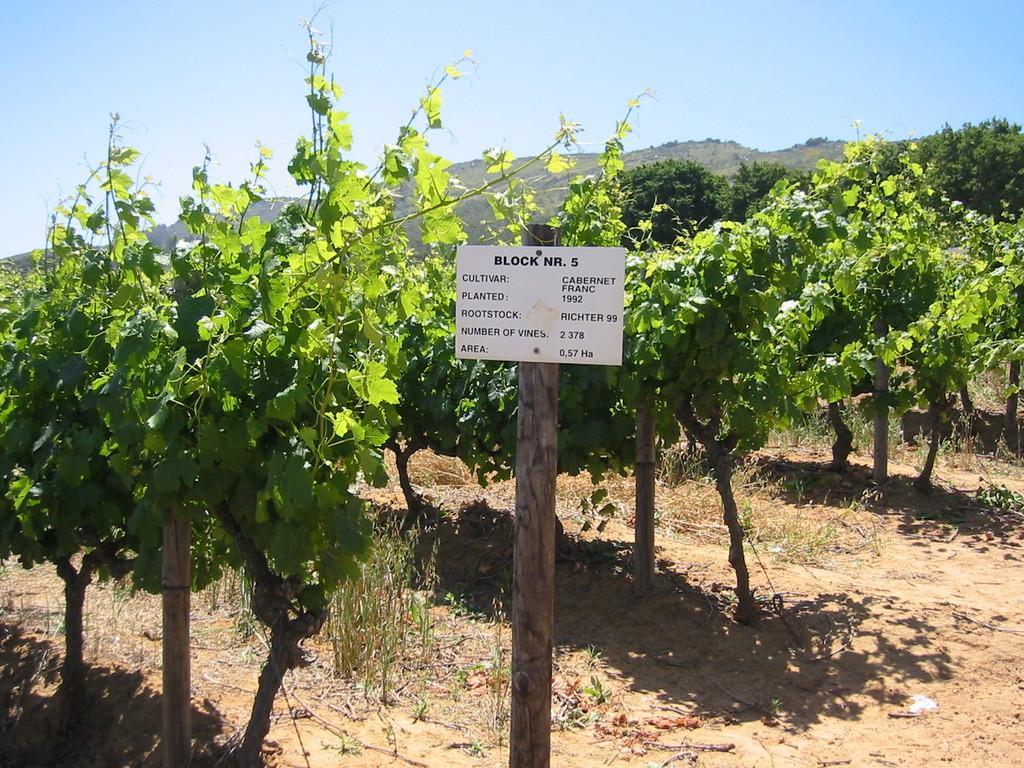Describe this image in one or two sentences. In the picture there are many plants present, there is a pole with the board, on the board there is a text, there are mountains, there is a clear sky. 